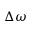<formula> <loc_0><loc_0><loc_500><loc_500>\Delta \omega</formula> 